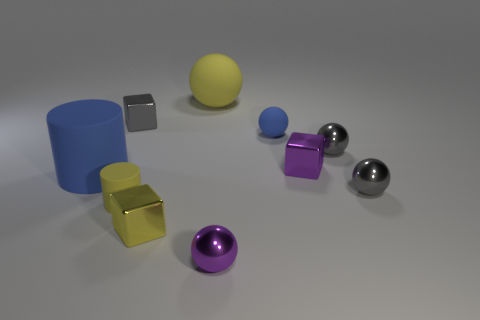Subtract all tiny purple balls. How many balls are left? 4 Subtract all blue cylinders. How many cylinders are left? 1 Subtract 1 cylinders. How many cylinders are left? 1 Subtract 0 purple cylinders. How many objects are left? 10 Subtract all cylinders. How many objects are left? 8 Subtract all purple spheres. Subtract all purple cylinders. How many spheres are left? 4 Subtract all green cylinders. How many gray balls are left? 2 Subtract all blue spheres. Subtract all small blocks. How many objects are left? 6 Add 2 tiny cylinders. How many tiny cylinders are left? 3 Add 6 small yellow shiny objects. How many small yellow shiny objects exist? 7 